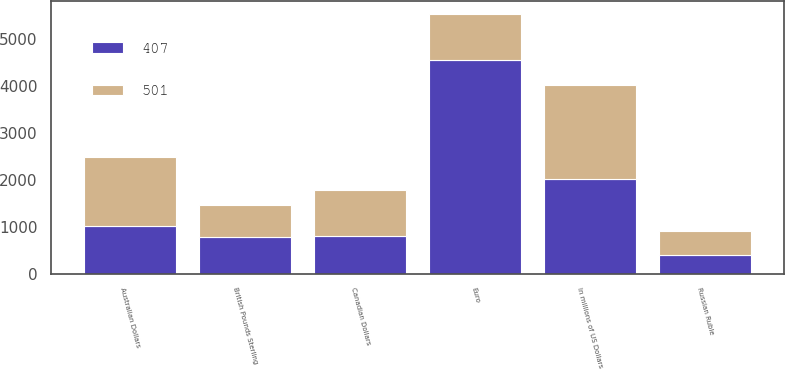<chart> <loc_0><loc_0><loc_500><loc_500><stacked_bar_chart><ecel><fcel>In millions of US Dollars<fcel>Euro<fcel>Australian Dollars<fcel>Canadian Dollars<fcel>British Pounds Sterling<fcel>Russian Ruble<nl><fcel>501<fcel>2009<fcel>981<fcel>1460<fcel>981<fcel>679<fcel>501<nl><fcel>407<fcel>2008<fcel>4551<fcel>1023<fcel>795<fcel>785<fcel>407<nl></chart> 